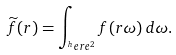<formula> <loc_0><loc_0><loc_500><loc_500>\widetilde { f } ( r ) = \int _ { ^ { h } e r e ^ { 2 } } f ( r \omega ) \, d \omega .</formula> 